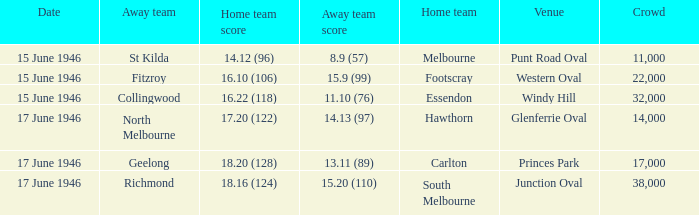12 (96)? Melbourne. 